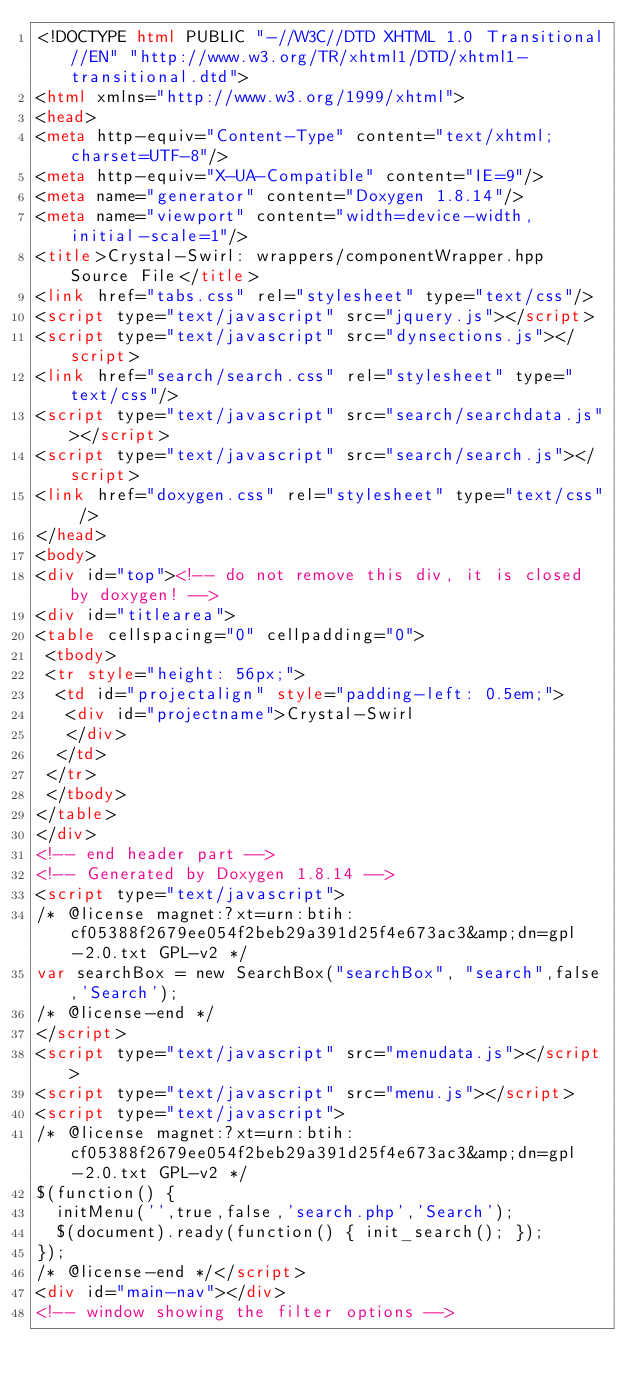Convert code to text. <code><loc_0><loc_0><loc_500><loc_500><_HTML_><!DOCTYPE html PUBLIC "-//W3C//DTD XHTML 1.0 Transitional//EN" "http://www.w3.org/TR/xhtml1/DTD/xhtml1-transitional.dtd">
<html xmlns="http://www.w3.org/1999/xhtml">
<head>
<meta http-equiv="Content-Type" content="text/xhtml;charset=UTF-8"/>
<meta http-equiv="X-UA-Compatible" content="IE=9"/>
<meta name="generator" content="Doxygen 1.8.14"/>
<meta name="viewport" content="width=device-width, initial-scale=1"/>
<title>Crystal-Swirl: wrappers/componentWrapper.hpp Source File</title>
<link href="tabs.css" rel="stylesheet" type="text/css"/>
<script type="text/javascript" src="jquery.js"></script>
<script type="text/javascript" src="dynsections.js"></script>
<link href="search/search.css" rel="stylesheet" type="text/css"/>
<script type="text/javascript" src="search/searchdata.js"></script>
<script type="text/javascript" src="search/search.js"></script>
<link href="doxygen.css" rel="stylesheet" type="text/css" />
</head>
<body>
<div id="top"><!-- do not remove this div, it is closed by doxygen! -->
<div id="titlearea">
<table cellspacing="0" cellpadding="0">
 <tbody>
 <tr style="height: 56px;">
  <td id="projectalign" style="padding-left: 0.5em;">
   <div id="projectname">Crystal-Swirl
   </div>
  </td>
 </tr>
 </tbody>
</table>
</div>
<!-- end header part -->
<!-- Generated by Doxygen 1.8.14 -->
<script type="text/javascript">
/* @license magnet:?xt=urn:btih:cf05388f2679ee054f2beb29a391d25f4e673ac3&amp;dn=gpl-2.0.txt GPL-v2 */
var searchBox = new SearchBox("searchBox", "search",false,'Search');
/* @license-end */
</script>
<script type="text/javascript" src="menudata.js"></script>
<script type="text/javascript" src="menu.js"></script>
<script type="text/javascript">
/* @license magnet:?xt=urn:btih:cf05388f2679ee054f2beb29a391d25f4e673ac3&amp;dn=gpl-2.0.txt GPL-v2 */
$(function() {
  initMenu('',true,false,'search.php','Search');
  $(document).ready(function() { init_search(); });
});
/* @license-end */</script>
<div id="main-nav"></div>
<!-- window showing the filter options --></code> 